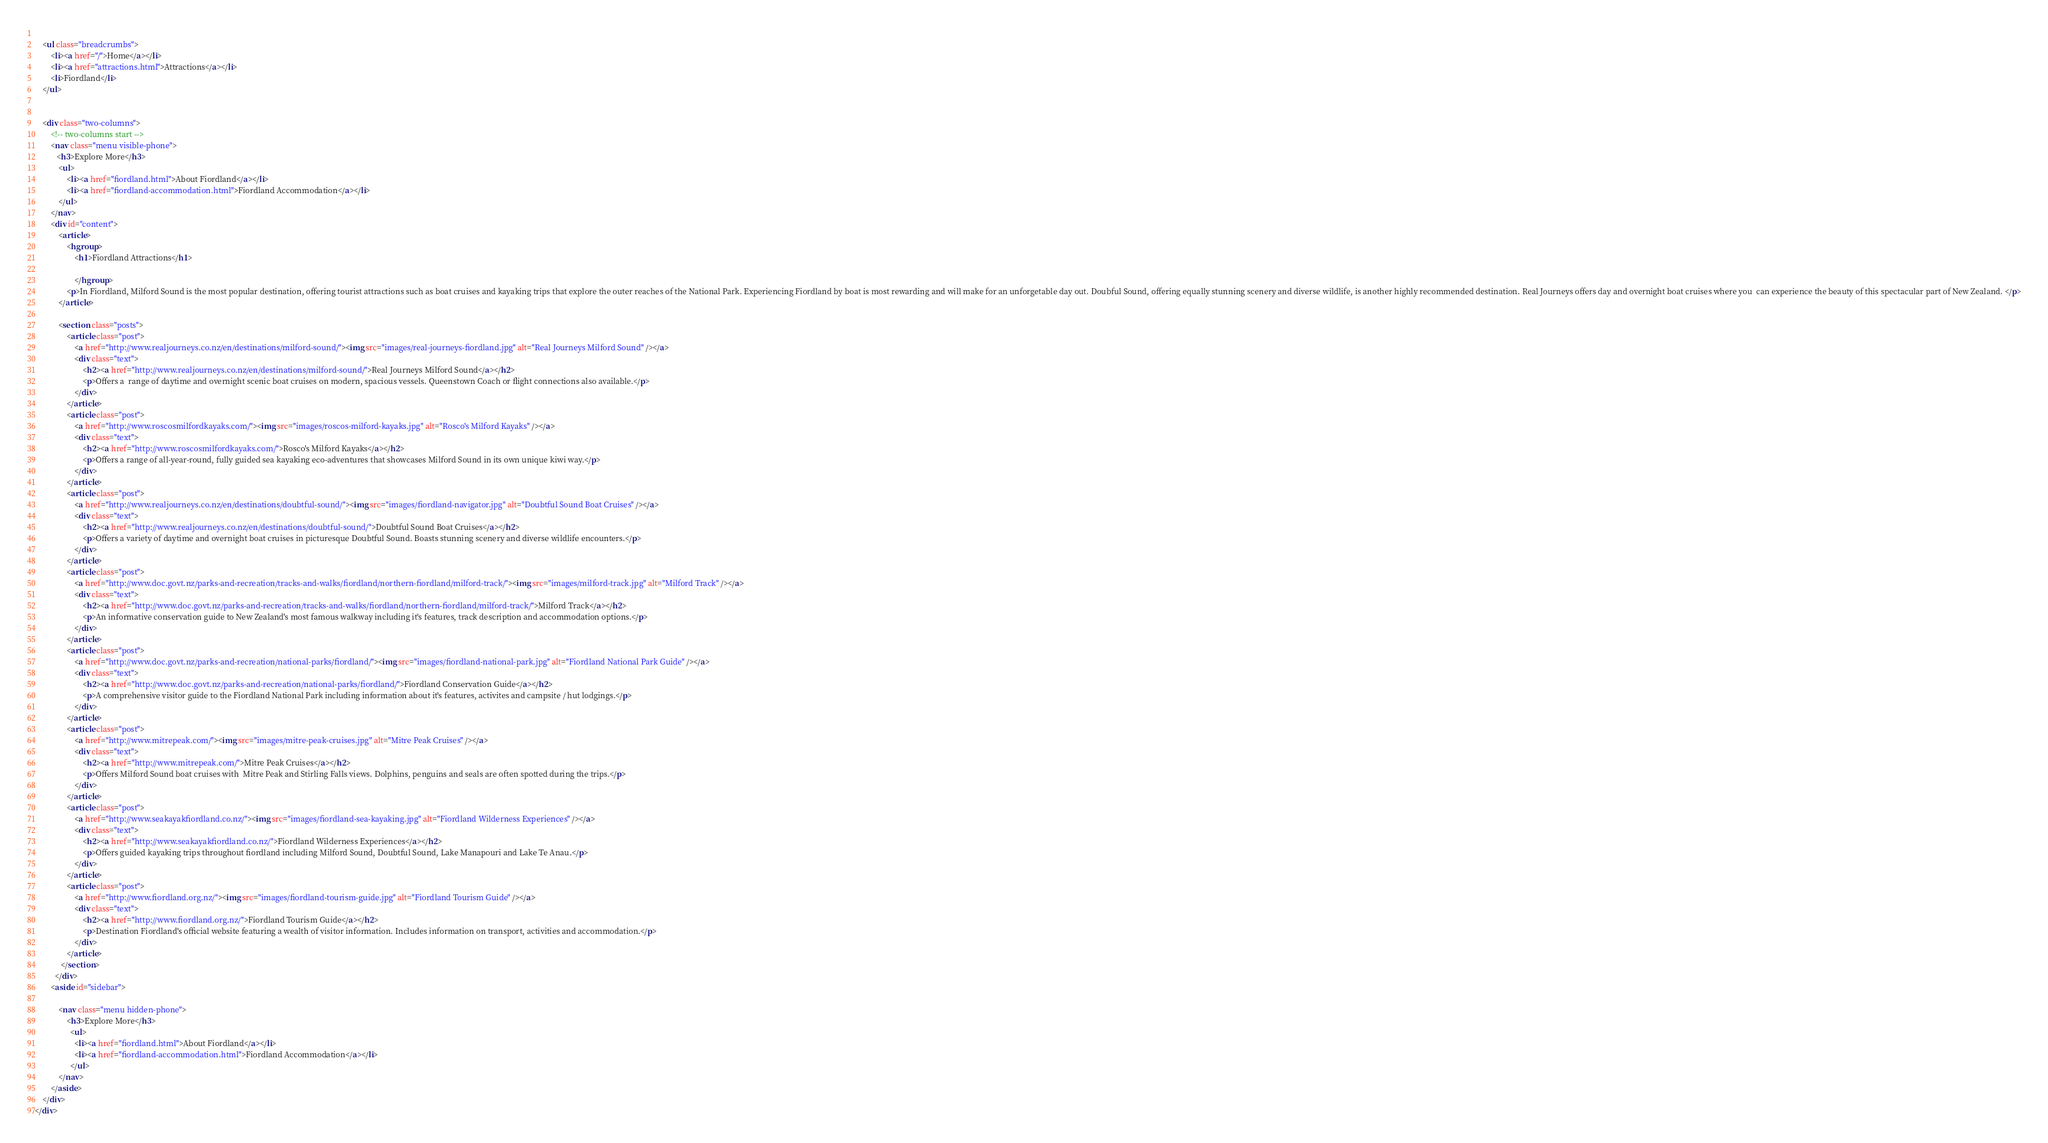Convert code to text. <code><loc_0><loc_0><loc_500><loc_500><_HTML_>	
    <ul class="breadcrumbs">
		<li><a href="/">Home</a></li>
		<li><a href="attractions.html">Attractions</a></li>
		<li>Fiordland</li>
    </ul>

         	
	<div class="two-columns">
		<!-- two-columns start -->
		<nav class="menu visible-phone">
		   <h3>Explore More</h3>
			<ul>
				<li><a href="fiordland.html">About Fiordland</a></li>
                <li><a href="fiordland-accommodation.html">Fiordland Accommodation</a></li>                        
			</ul>
		</nav>
		<div id="content">
			<article>
            	<hgroup>
					<h1>Fiordland Attractions</h1>
                    
					</hgroup>
                <p>In Fiordland, Milford Sound is the most popular destination, offering tourist attractions such as boat cruises and kayaking trips that explore the outer reaches of the National Park. Experiencing Fiordland by boat is most rewarding and will make for an unforgetable day out. Doubful Sound, offering equally stunning scenery and diverse wildlife, is another highly recommended destination. Real Journeys offers day and overnight boat cruises where you  can experience the beauty of this spectacular part of New Zealand. </p>
			</article>
            
            <section class="posts">
				<article class="post">
					<a href="http://www.realjourneys.co.nz/en/destinations/milford-sound/"><img src="images/real-journeys-fiordland.jpg" alt="Real Journeys Milford Sound" /></a>
					<div class="text">
						<h2><a href="http://www.realjourneys.co.nz/en/destinations/milford-sound/">Real Journeys Milford Sound</a></h2>
						<p>Offers a  range of daytime and overnight scenic boat cruises on modern, spacious vessels. Queenstown Coach or flight connections also available.</p>
					</div>
				</article>  
                <article class="post">
					<a href="http://www.roscosmilfordkayaks.com/"><img src="images/roscos-milford-kayaks.jpg" alt="Rosco's Milford Kayaks" /></a>
					<div class="text">
						<h2><a href="http://www.roscosmilfordkayaks.com/">Rosco's Milford Kayaks</a></h2>
						<p>Offers a range of all-year-round, fully guided sea kayaking eco-adventures that showcases Milford Sound in its own unique kiwi way.</p>
					</div>
				</article>                                               
                <article class="post">
					<a href="http://www.realjourneys.co.nz/en/destinations/doubtful-sound/"><img src="images/fiordland-navigator.jpg" alt="Doubtful Sound Boat Cruises" /></a>
					<div class="text">
						<h2><a href="http://www.realjourneys.co.nz/en/destinations/doubtful-sound/">Doubtful Sound Boat Cruises</a></h2>
						<p>Offers a variety of daytime and overnight boat cruises in picturesque Doubtful Sound. Boasts stunning scenery and diverse wildlife encounters.</p>
					</div>
				</article>                                  
                <article class="post">
					<a href="http://www.doc.govt.nz/parks-and-recreation/tracks-and-walks/fiordland/northern-fiordland/milford-track/"><img src="images/milford-track.jpg" alt="Milford Track" /></a>
					<div class="text">
						<h2><a href="http://www.doc.govt.nz/parks-and-recreation/tracks-and-walks/fiordland/northern-fiordland/milford-track/">Milford Track</a></h2>
						<p>An informative conservation guide to New Zealand's most famous walkway including it's features, track description and accommodation options.</p>
					</div>
				</article>                      
                <article class="post">
					<a href="http://www.doc.govt.nz/parks-and-recreation/national-parks/fiordland/"><img src="images/fiordland-national-park.jpg" alt="Fiordland National Park Guide" /></a>
					<div class="text">
						<h2><a href="http://www.doc.govt.nz/parks-and-recreation/national-parks/fiordland/">Fiordland Conservation Guide</a></h2>
						<p>A comprehensive visitor guide to the Fiordland National Park including information about it's features, activites and campsite / hut lodgings.</p>
					</div>
				</article>                        
                <article class="post">
					<a href="http://www.mitrepeak.com/"><img src="images/mitre-peak-cruises.jpg" alt="Mitre Peak Cruises" /></a>
					<div class="text">
						<h2><a href="http://www.mitrepeak.com/">Mitre Peak Cruises</a></h2>
						<p>Offers Milford Sound boat cruises with  Mitre Peak and Stirling Falls views. Dolphins, penguins and seals are often spotted during the trips.</p>
					</div>
				</article>   
                <article class="post">
					<a href="http://www.seakayakfiordland.co.nz/"><img src="images/fiordland-sea-kayaking.jpg" alt="Fiordland Wilderness Experiences" /></a>
					<div class="text">
						<h2><a href="http://www.seakayakfiordland.co.nz/">Fiordland Wilderness Experiences</a></h2>
						<p>Offers guided kayaking trips throughout fiordland including Milford Sound, Doubtful Sound, Lake Manapouri and Lake Te Anau.</p>
					</div>
				</article>                              
                <article class="post">
					<a href="http://www.fiordland.org.nz/"><img src="images/fiordland-tourism-guide.jpg" alt="Fiordland Tourism Guide" /></a>
					<div class="text">
						<h2><a href="http://www.fiordland.org.nz/">Fiordland Tourism Guide</a></h2>
						<p>Destination Fiordland's official website featuring a wealth of visitor information. Includes information on transport, activities and accommodation.</p>
					</div>
				</article>                                                            	                              
             </section>
          </div>
		<aside id="sidebar">
            
			<nav class="menu hidden-phone">
				<h3>Explore More</h3>
				  <ul>
				    <li><a href="fiordland.html">About Fiordland</a></li>
                    <li><a href="fiordland-accommodation.html">Fiordland Accommodation</a></li>                            
				  </ul>
			</nav>
		</aside>
	</div>
</div></code> 